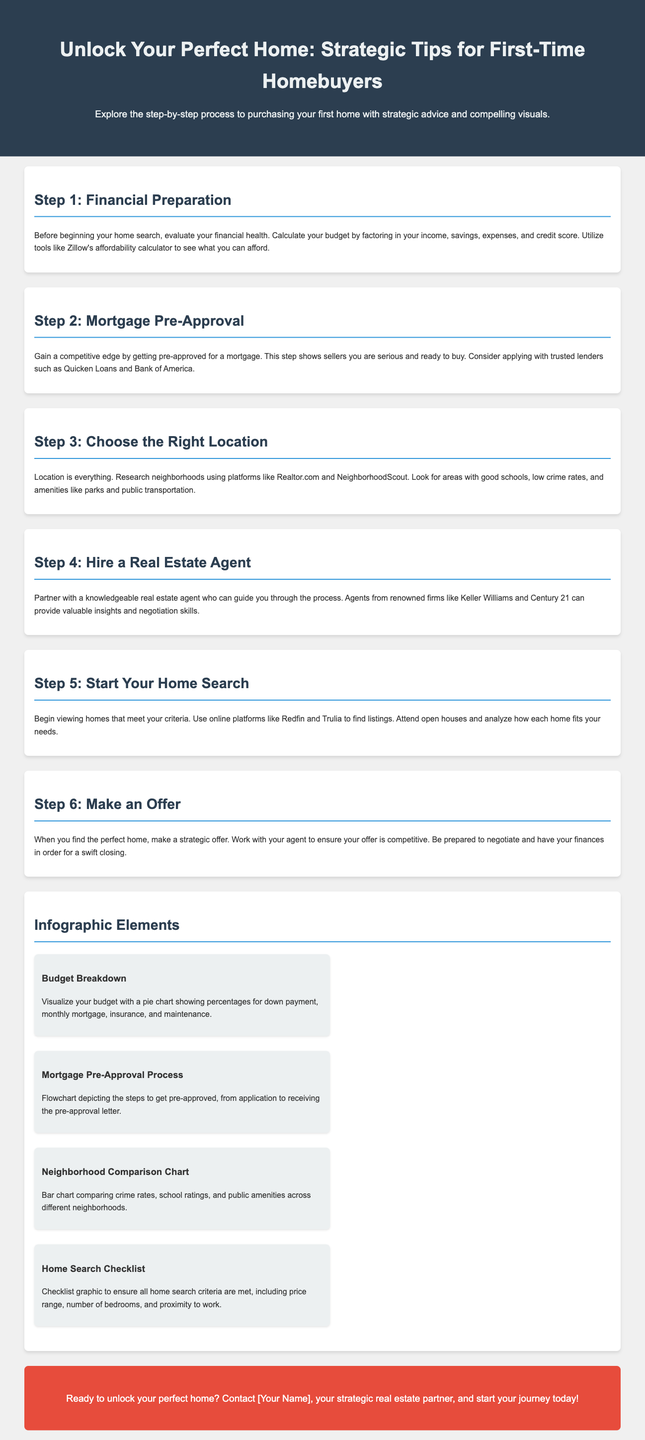what is the title of the document? The title of the document is presented in a prominent header, clearly stating the main theme of the advertisement.
Answer: Unlock Your Perfect Home: Strategic Tips for First-Time Homebuyers what is step 1 in the buying process? The steps are listed sequentially, providing a roadmap for first-time homebuyers. Step 1 focuses on financial readiness.
Answer: Financial Preparation which platforms are suggested for neighborhood research? The document suggests specific platforms for researching neighborhoods, emphasizing their utility in finding the right location.
Answer: Realtor.com and NeighborhoodScout what should you do before making an offer on a home? Important actions that should be taken prior to making an offer are outlined, emphasizing readiness and strategy.
Answer: Have your finances in order how many infographic elements are listed in the document? The document includes a section dedicated to infographics that visually summarize key information in the home buying process.
Answer: Four which real estate firms are recommended for hiring an agent? The document mentions notable firms to consider when looking for a real estate agent, highlighting their reputation in the industry.
Answer: Keller Williams and Century 21 what type of graphic is suggested for visualizing a budget? The document provides specific suggestions on how to represent financial information effectively, helping buyers understand their financial commitments.
Answer: Pie chart who should you contact to start your home-buying journey? The document includes a call to action, encouraging potential homebuyers to reach out for assistance.
Answer: [Your Name] 